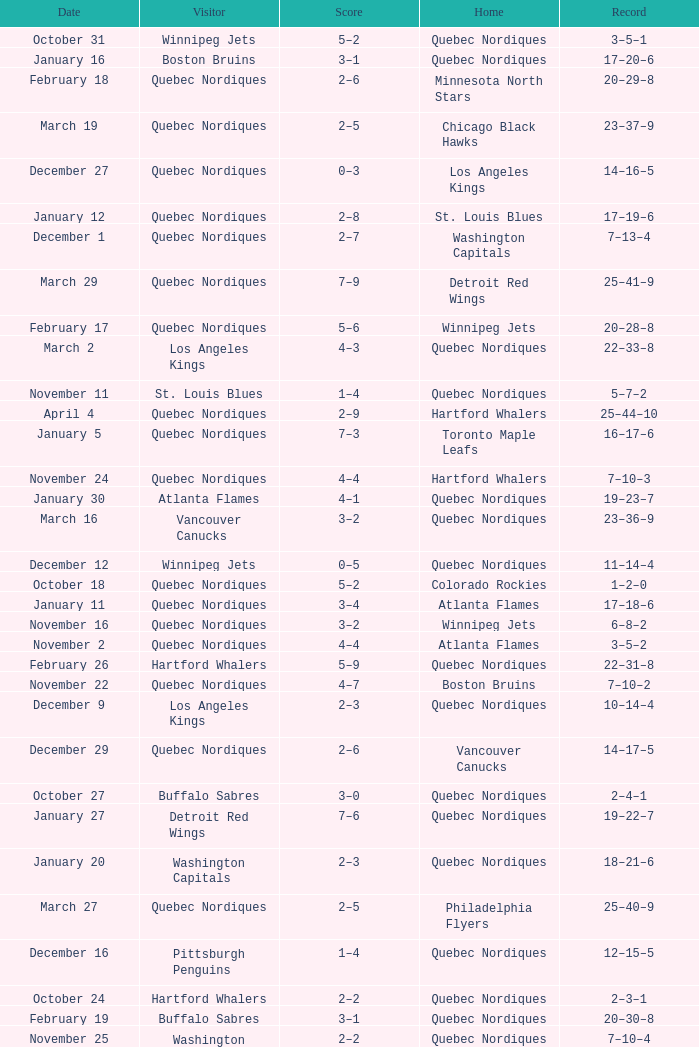Which Date has a Score of 2–7, and a Record of 5–8–2? November 14. 